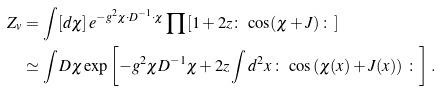<formula> <loc_0><loc_0><loc_500><loc_500>Z _ { v } & = \int [ d \chi ] \, e ^ { - g ^ { 2 } \chi \cdot D ^ { - 1 } \cdot \chi } \prod \left [ 1 + 2 z \colon \, \cos ( \chi + J ) \, \colon \right ] \\ & \simeq \int D \chi \exp \left [ - g ^ { 2 } \chi D ^ { - 1 } \chi + 2 z \int d ^ { 2 } x \, \colon \, \cos \left ( \chi ( x ) + J ( x ) \right ) \, \colon \right ] \, .</formula> 